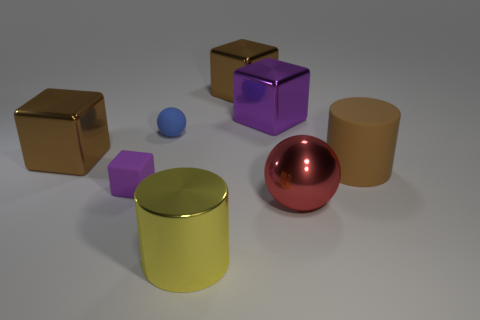Subtract all shiny cubes. How many cubes are left? 1 Subtract all balls. How many objects are left? 6 Subtract 3 blocks. How many blocks are left? 1 Add 2 small green objects. How many objects exist? 10 Subtract all yellow cylinders. How many cylinders are left? 1 Subtract all purple cylinders. How many brown cubes are left? 2 Subtract all big brown blocks. Subtract all large red things. How many objects are left? 5 Add 4 big brown cylinders. How many big brown cylinders are left? 5 Add 2 small matte spheres. How many small matte spheres exist? 3 Subtract 1 blue spheres. How many objects are left? 7 